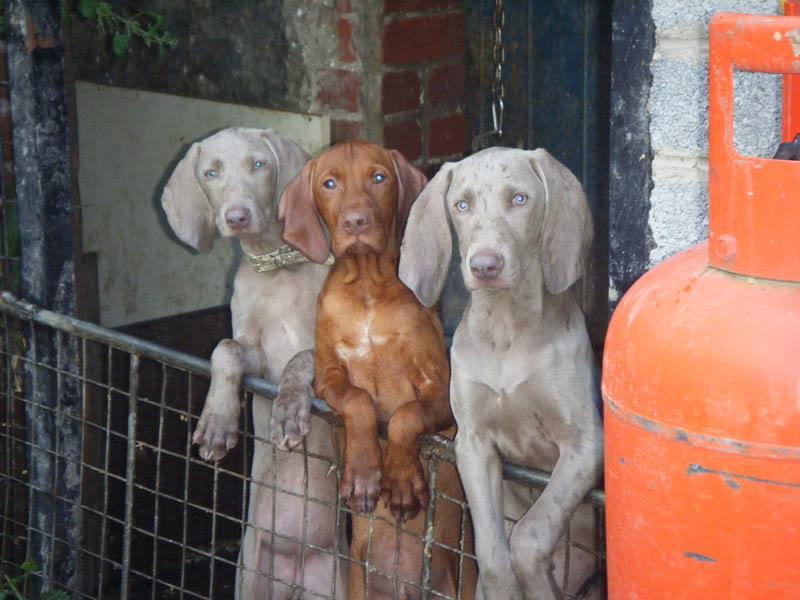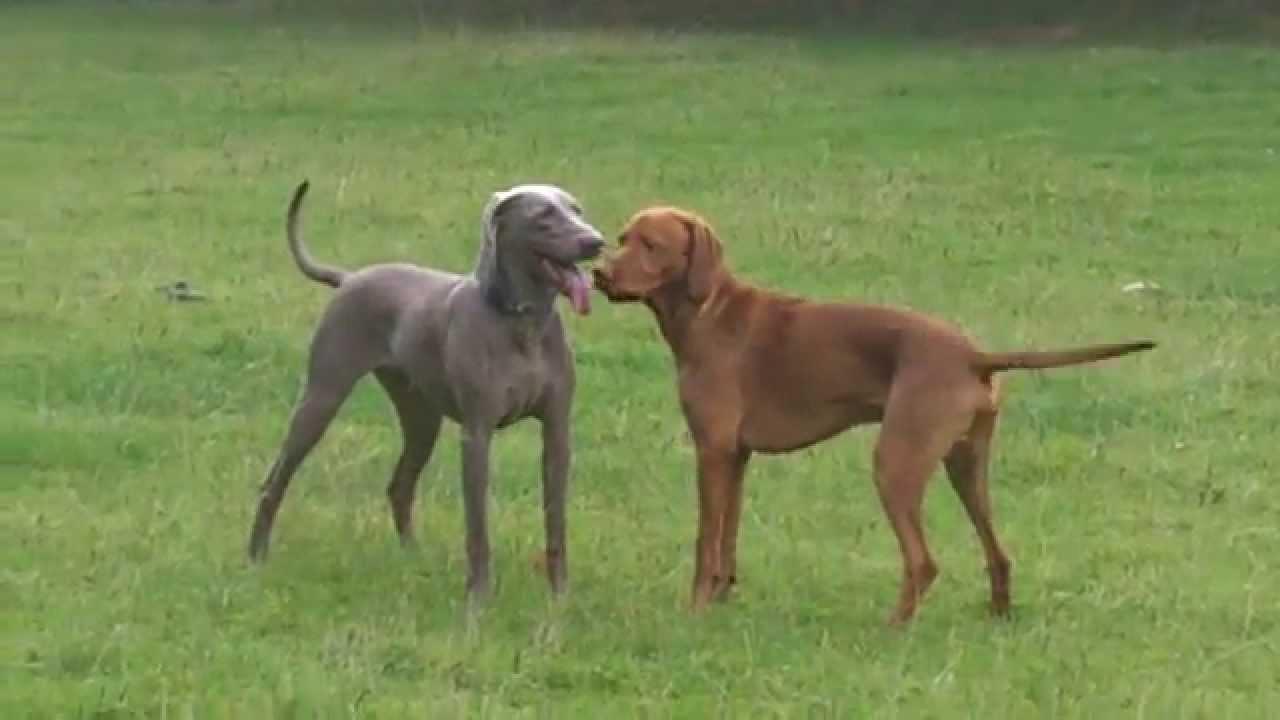The first image is the image on the left, the second image is the image on the right. Evaluate the accuracy of this statement regarding the images: "There are exactly two dogs in both images.". Is it true? Answer yes or no. No. 